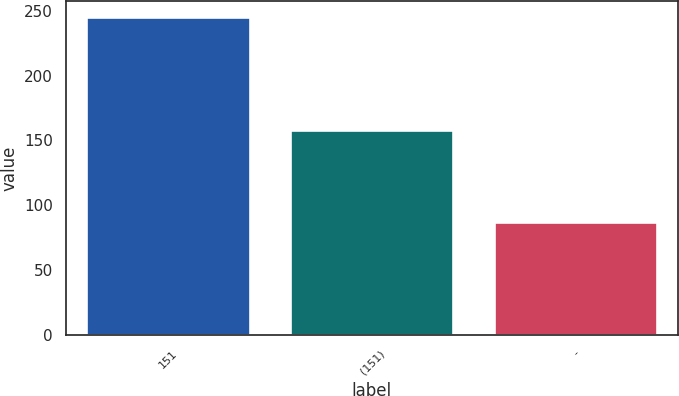<chart> <loc_0><loc_0><loc_500><loc_500><bar_chart><fcel>151<fcel>(151)<fcel>-<nl><fcel>245<fcel>158<fcel>87<nl></chart> 